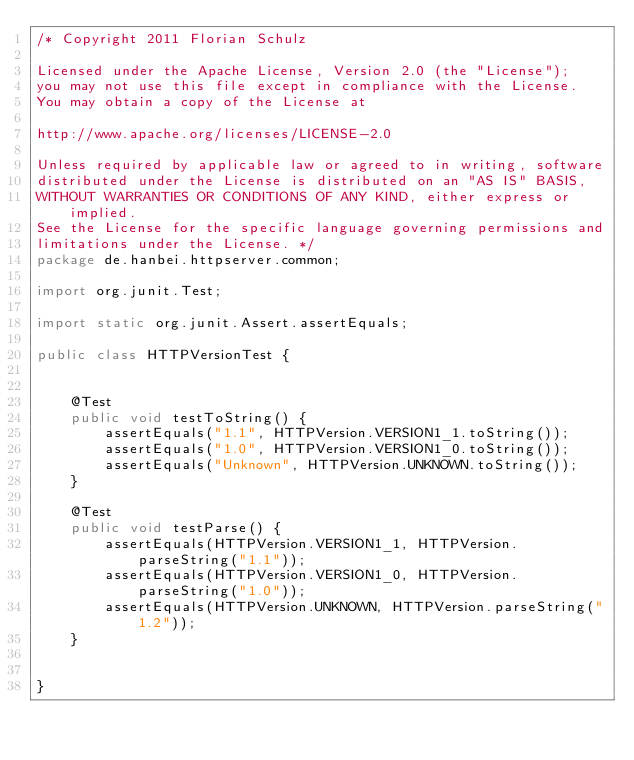Convert code to text. <code><loc_0><loc_0><loc_500><loc_500><_Java_>/* Copyright 2011 Florian Schulz

Licensed under the Apache License, Version 2.0 (the "License");
you may not use this file except in compliance with the License.
You may obtain a copy of the License at

http://www.apache.org/licenses/LICENSE-2.0

Unless required by applicable law or agreed to in writing, software
distributed under the License is distributed on an "AS IS" BASIS,
WITHOUT WARRANTIES OR CONDITIONS OF ANY KIND, either express or implied.
See the License for the specific language governing permissions and
limitations under the License. */
package de.hanbei.httpserver.common;

import org.junit.Test;

import static org.junit.Assert.assertEquals;

public class HTTPVersionTest {


    @Test
    public void testToString() {
        assertEquals("1.1", HTTPVersion.VERSION1_1.toString());
        assertEquals("1.0", HTTPVersion.VERSION1_0.toString());
        assertEquals("Unknown", HTTPVersion.UNKNOWN.toString());
    }

    @Test
    public void testParse() {
        assertEquals(HTTPVersion.VERSION1_1, HTTPVersion.parseString("1.1"));
        assertEquals(HTTPVersion.VERSION1_0, HTTPVersion.parseString("1.0"));
        assertEquals(HTTPVersion.UNKNOWN, HTTPVersion.parseString("1.2"));
    }


}
</code> 